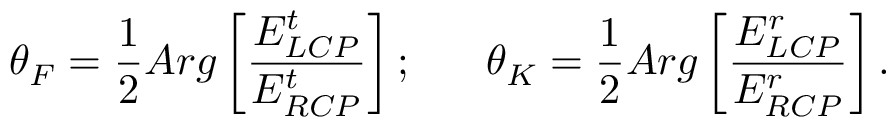Convert formula to latex. <formula><loc_0><loc_0><loc_500><loc_500>\theta _ { F } = \frac { 1 } { 2 } A r g \left [ \frac { E _ { L C P } ^ { t } } { E _ { R C P } ^ { t } } \right ] ; \theta _ { K } = \frac { 1 } { 2 } A r g \left [ \frac { E _ { L C P } ^ { r } } { E _ { R C P } ^ { r } } \right ] .</formula> 